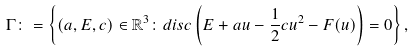Convert formula to latex. <formula><loc_0><loc_0><loc_500><loc_500>\Gamma \colon = \left \{ ( a , E , c ) \in \mathbb { R } ^ { 3 } \colon d i s c \left ( E + a u - \frac { 1 } { 2 } c u ^ { 2 } - F ( u ) \right ) = 0 \right \} ,</formula> 